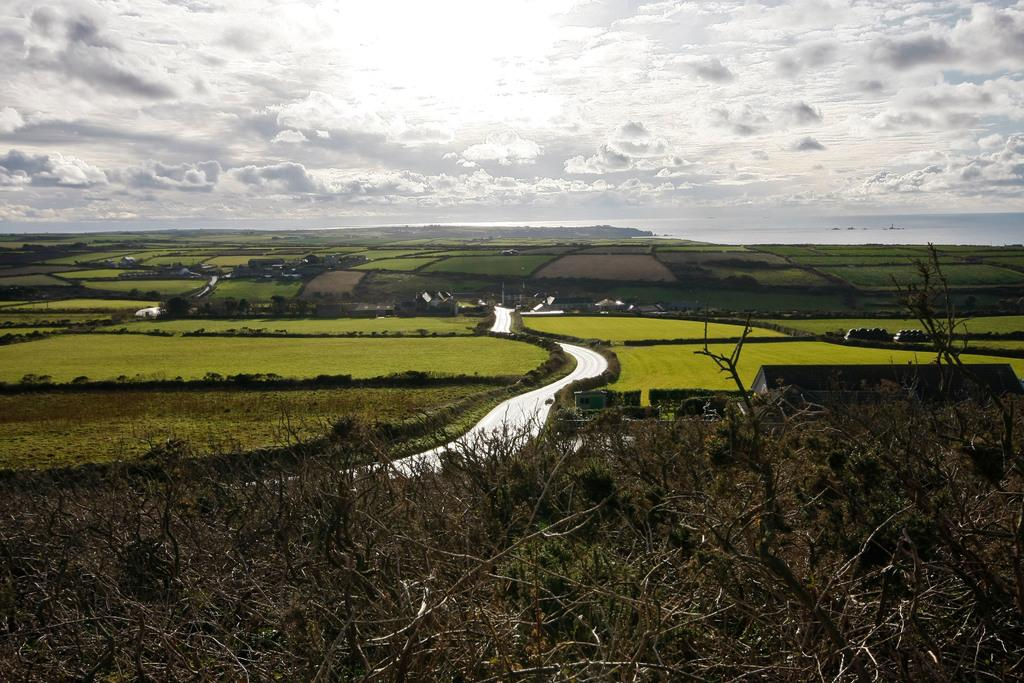What is the main feature of the image? A: There is a road in the image. What can be seen in the background of the image? There is green grass visible in the background. What is visible at the top of the image? The sky is visible at the top of the image. What can be observed in the sky? Clouds are present in the sky. How many babies are crawling on the road in the image? There are no babies present in the image; it only features a road, green grass in the background, and clouds in the sky. 